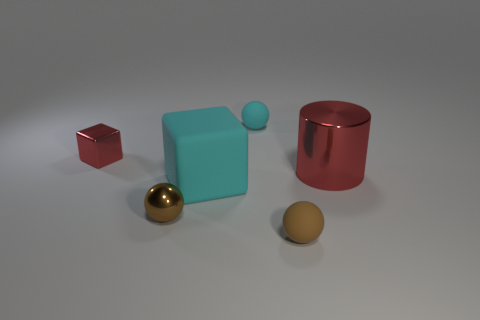What kind of surface are these objects placed on? The objects are placed on a smooth, matte surface that doesn't reflect much light, which suggests that it could be a type of frosted glass or a matte-finished plastic. Its neutral grey tone provides a non-distracting background that allows the colors and textures of the objects to stand out.  If these objects were part of a game, what rules can you imagine would be involved? If these objects were part of a game, we might imagine a sorting challenge where players must arrange the objects by material or color within a time limit. Another possibility could involve spatial reasoning, like a puzzle where players must fit the objects into a specified area in a certain way. The varying shapes could lend themselves to a creative assortment of gameplay mechanics. 